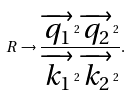Convert formula to latex. <formula><loc_0><loc_0><loc_500><loc_500>R \rightarrow \frac { \overrightarrow { q _ { 1 } } ^ { 2 } \overrightarrow { q _ { 2 } } ^ { 2 } } { \overrightarrow { k _ { 1 } } ^ { 2 } \overrightarrow { k _ { 2 } } ^ { 2 } } .</formula> 